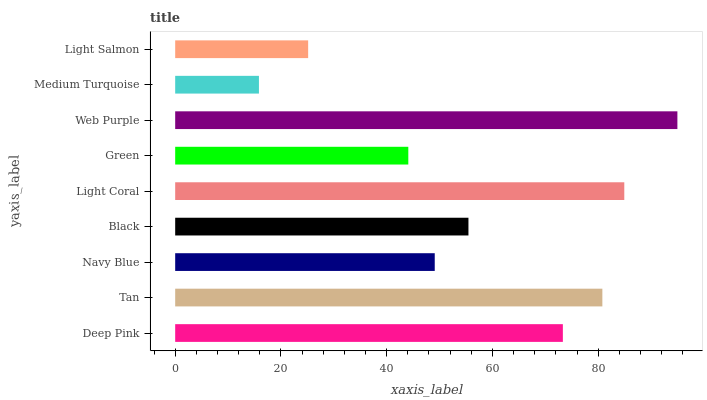Is Medium Turquoise the minimum?
Answer yes or no. Yes. Is Web Purple the maximum?
Answer yes or no. Yes. Is Tan the minimum?
Answer yes or no. No. Is Tan the maximum?
Answer yes or no. No. Is Tan greater than Deep Pink?
Answer yes or no. Yes. Is Deep Pink less than Tan?
Answer yes or no. Yes. Is Deep Pink greater than Tan?
Answer yes or no. No. Is Tan less than Deep Pink?
Answer yes or no. No. Is Black the high median?
Answer yes or no. Yes. Is Black the low median?
Answer yes or no. Yes. Is Web Purple the high median?
Answer yes or no. No. Is Deep Pink the low median?
Answer yes or no. No. 